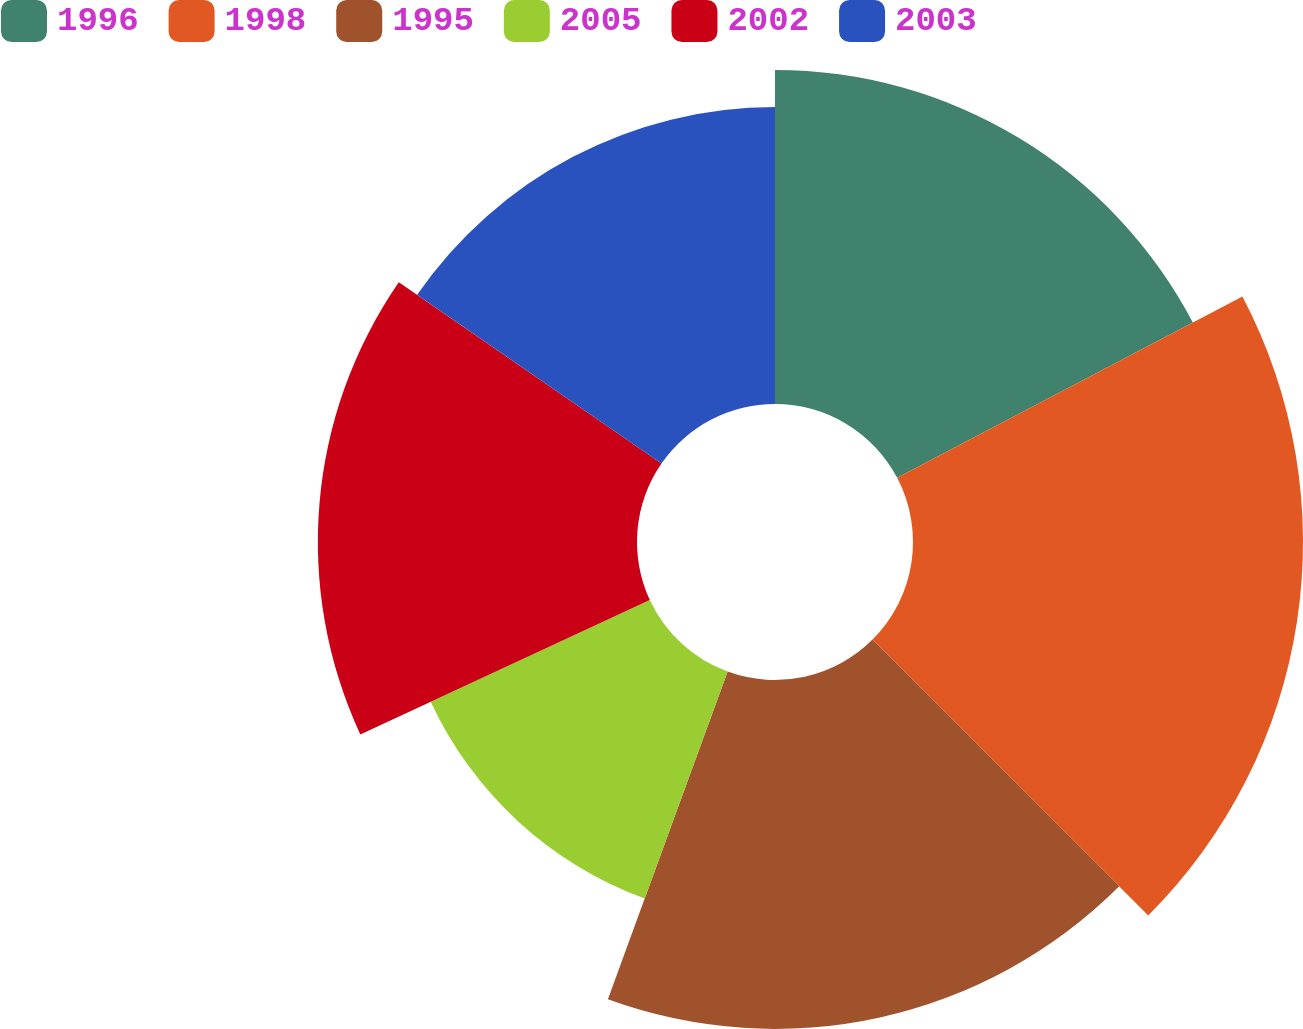Convert chart to OTSL. <chart><loc_0><loc_0><loc_500><loc_500><pie_chart><fcel>1996<fcel>1998<fcel>1995<fcel>2005<fcel>2002<fcel>2003<nl><fcel>17.3%<fcel>20.2%<fcel>18.07%<fcel>12.51%<fcel>16.53%<fcel>15.38%<nl></chart> 